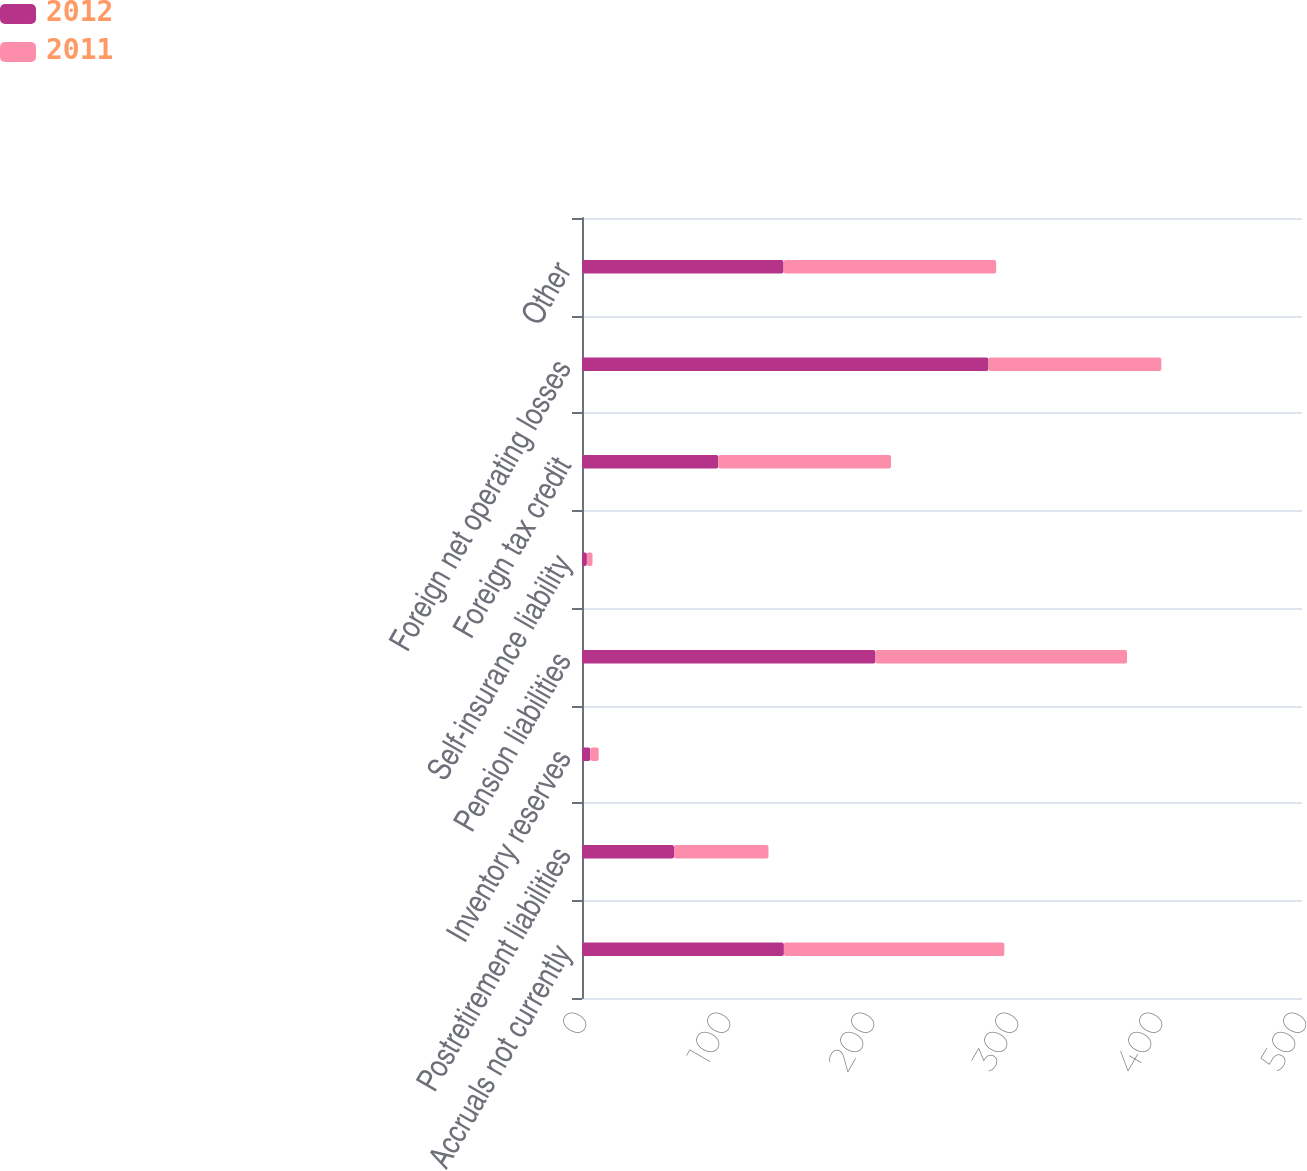Convert chart to OTSL. <chart><loc_0><loc_0><loc_500><loc_500><stacked_bar_chart><ecel><fcel>Accruals not currently<fcel>Postretirement liabilities<fcel>Inventory reserves<fcel>Pension liabilities<fcel>Self-insurance liability<fcel>Foreign tax credit<fcel>Foreign net operating losses<fcel>Other<nl><fcel>2012<fcel>140.2<fcel>63.9<fcel>5.8<fcel>203.8<fcel>3.4<fcel>94.6<fcel>282.3<fcel>140<nl><fcel>2011<fcel>153.1<fcel>65.6<fcel>5.8<fcel>174.7<fcel>3.9<fcel>120<fcel>120<fcel>147.6<nl></chart> 